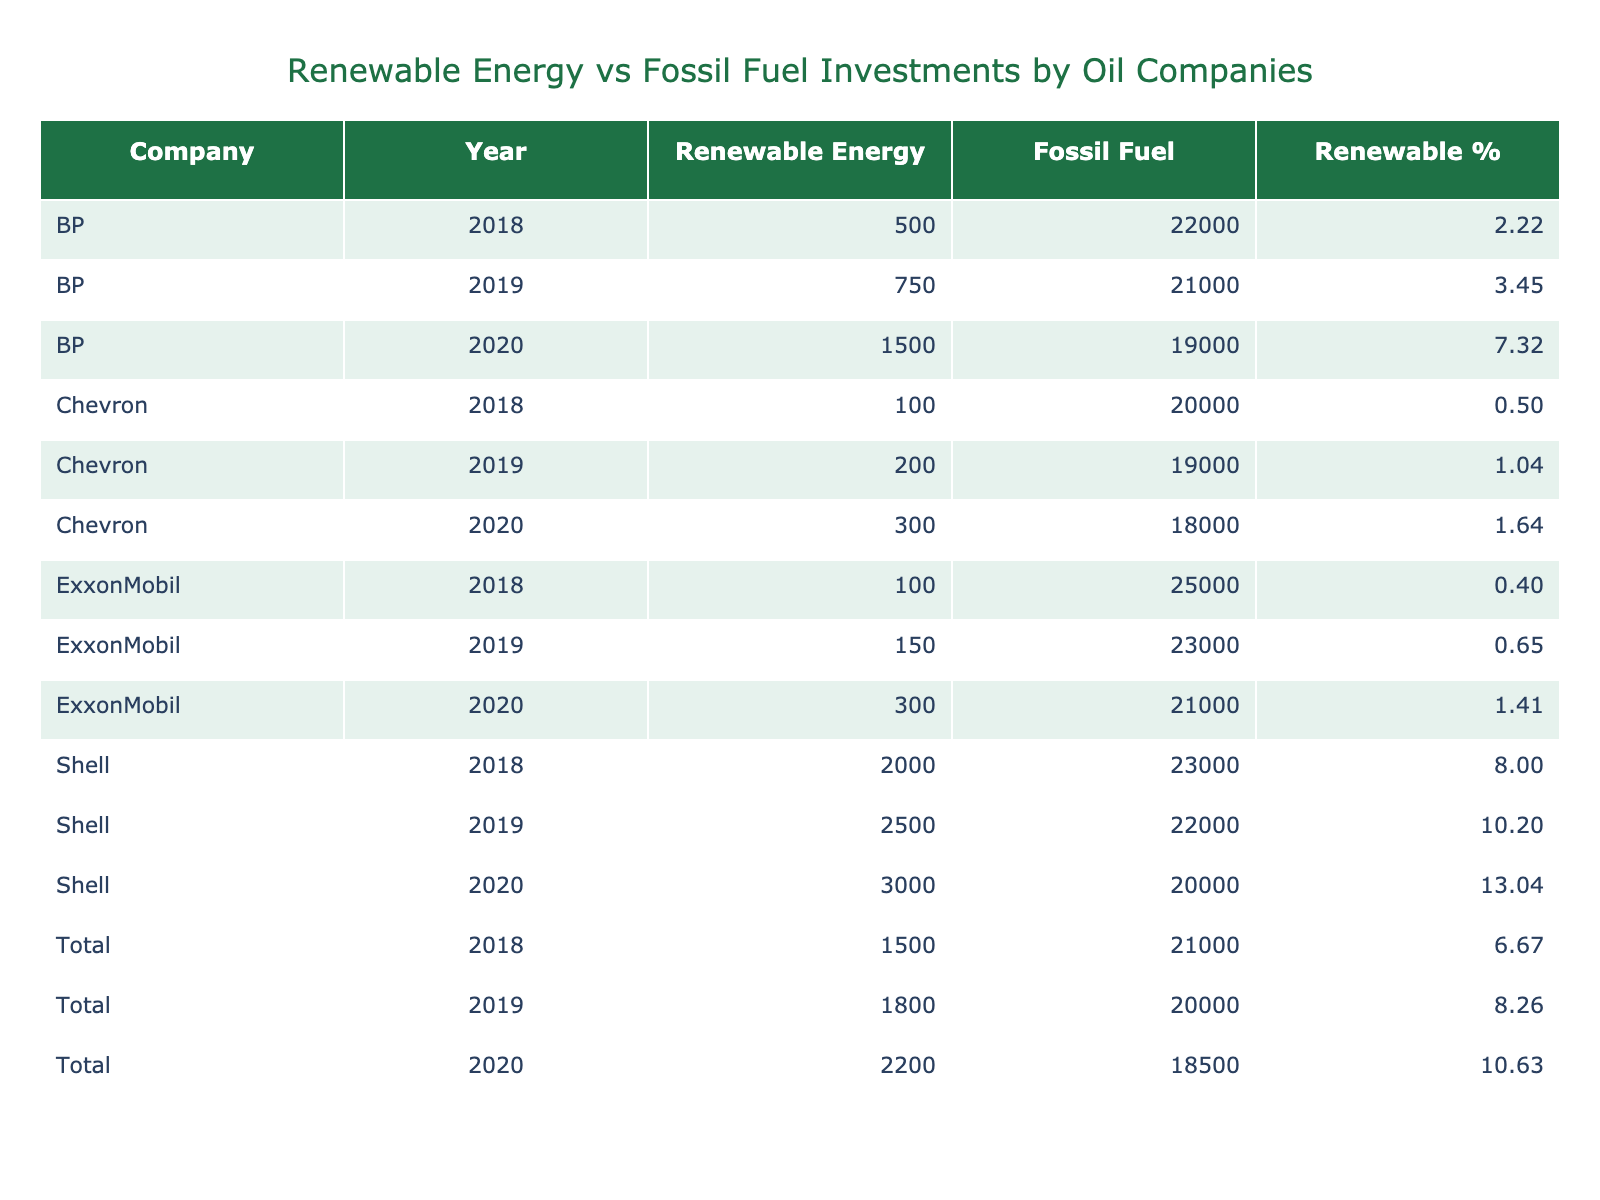What was the total renewable energy investment by BP in 2020? BP's renewable energy investment in 2020 is recorded as 1500 million USD, which can be found in the relevant row in the table.
Answer: 1500 million USD Which company had the highest fossil fuel expenditure in 2019? By examining the fossil fuel expenditures for each company in 2019, we see that Shell had the highest amount at 22000 million USD.
Answer: Shell What is the average renewable energy investment across all companies in 2018? To find the average, we add up the renewable energy investments in 2018: (100 + 2000 + 500 + 1500) = 3100 million USD. There are 4 entries, so the average is 3100 / 4 = 775 million USD.
Answer: 775 million USD Did Chevron increase or decrease their renewable energy investment from 2018 to 2020? In 2018, Chevron invested 100 million USD and in 2020, the investment was 300 million USD. Since 300 is greater than 100, this indicates an increase in investment.
Answer: Increase What percentage of Shell's total investment (renewable energy plus fossil fuel) in 2019 was renewable energy? Shell's total investment in 2019 was (2500 + 22000) = 24500 million USD. The renewable energy investment for that year was 2500 million USD. The percentage is (2500 / 24500) * 100 = 10.20%, rounded to 2 decimal places is 10.20%.
Answer: 10.20% How much more did ExxonMobil spend on fossil fuels than on renewable energy in 2020? In 2020, ExxonMobil spent 21000 million USD on fossil fuels and 300 million USD on renewable energy. The difference is 21000 - 300 = 20700 million USD, showing significantly higher spending on fossil fuels.
Answer: 20700 million USD Which company showed the highest percentage of renewable energy investment in 2019? By calculating the percentage for each company's investment in 2019: ExxonMobil (150 / 23150 = 0.65%), Shell (2500 / 24500 = 10.20%), BP (750 / 21750 = 3.45%), and Chevron (200 / 19200 = 1.04%). Shell shows the highest percentage at 10.20%.
Answer: Shell Is it true that Total increased their renewable energy investment every year from 2018 to 2020? In 2018, Total invested 1500 million USD, in 2019 it was 1800 million USD, and in 2020 it was 2200 million USD. Since each value is greater than the previous year, this statement is true.
Answer: True 